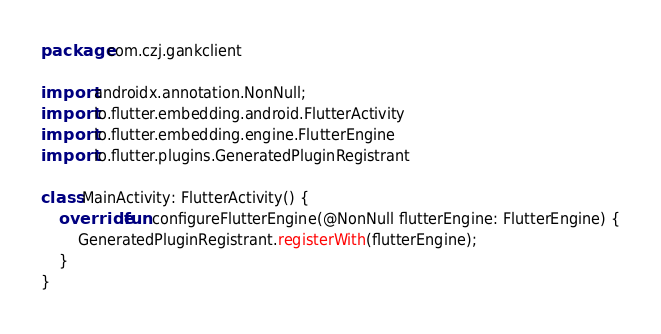<code> <loc_0><loc_0><loc_500><loc_500><_Kotlin_>package com.czj.gankclient

import androidx.annotation.NonNull;
import io.flutter.embedding.android.FlutterActivity
import io.flutter.embedding.engine.FlutterEngine
import io.flutter.plugins.GeneratedPluginRegistrant

class MainActivity: FlutterActivity() {
    override fun configureFlutterEngine(@NonNull flutterEngine: FlutterEngine) {
        GeneratedPluginRegistrant.registerWith(flutterEngine);
    }
}
</code> 